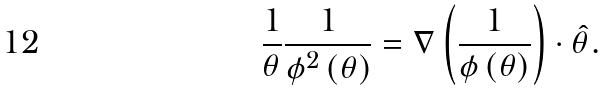Convert formula to latex. <formula><loc_0><loc_0><loc_500><loc_500>\frac { 1 } { \theta } \frac { 1 } { \phi ^ { 2 } \left ( \theta \right ) } = \nabla \left ( \frac { 1 } { \phi \left ( \theta \right ) } \right ) \cdot \hat { \theta } .</formula> 